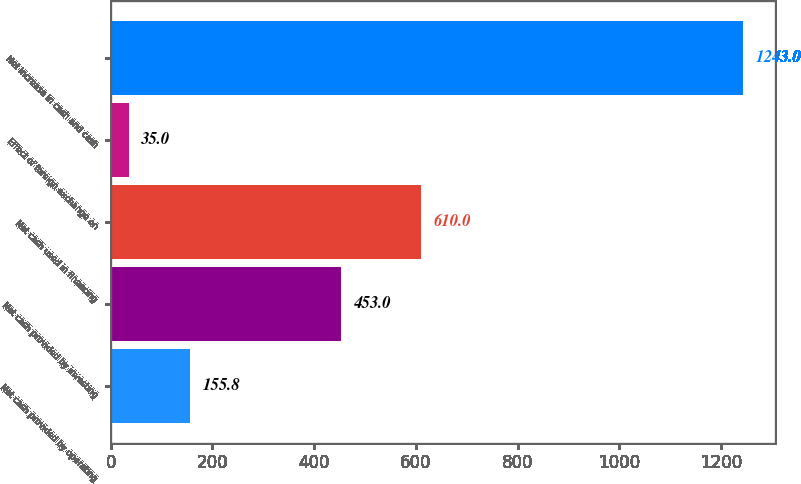Convert chart. <chart><loc_0><loc_0><loc_500><loc_500><bar_chart><fcel>Net cash provided by operating<fcel>Net cash provided by investing<fcel>Net cash used in financing<fcel>Effect of foreign exchange on<fcel>Net increase in cash and cash<nl><fcel>155.8<fcel>453<fcel>610<fcel>35<fcel>1243<nl></chart> 